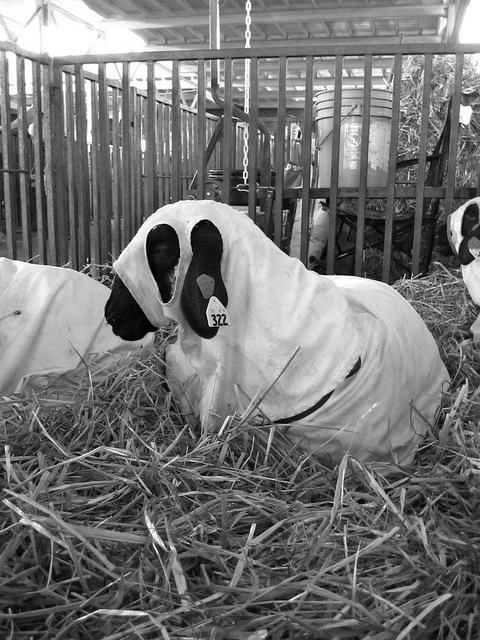Why does the animal have on number on his ear?
Answer briefly. Tagged. Are the animals standing?
Keep it brief. No. What is the animal laying on?
Quick response, please. Hay. 